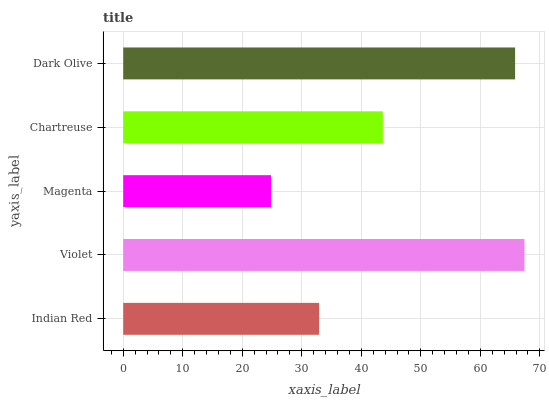Is Magenta the minimum?
Answer yes or no. Yes. Is Violet the maximum?
Answer yes or no. Yes. Is Violet the minimum?
Answer yes or no. No. Is Magenta the maximum?
Answer yes or no. No. Is Violet greater than Magenta?
Answer yes or no. Yes. Is Magenta less than Violet?
Answer yes or no. Yes. Is Magenta greater than Violet?
Answer yes or no. No. Is Violet less than Magenta?
Answer yes or no. No. Is Chartreuse the high median?
Answer yes or no. Yes. Is Chartreuse the low median?
Answer yes or no. Yes. Is Violet the high median?
Answer yes or no. No. Is Dark Olive the low median?
Answer yes or no. No. 